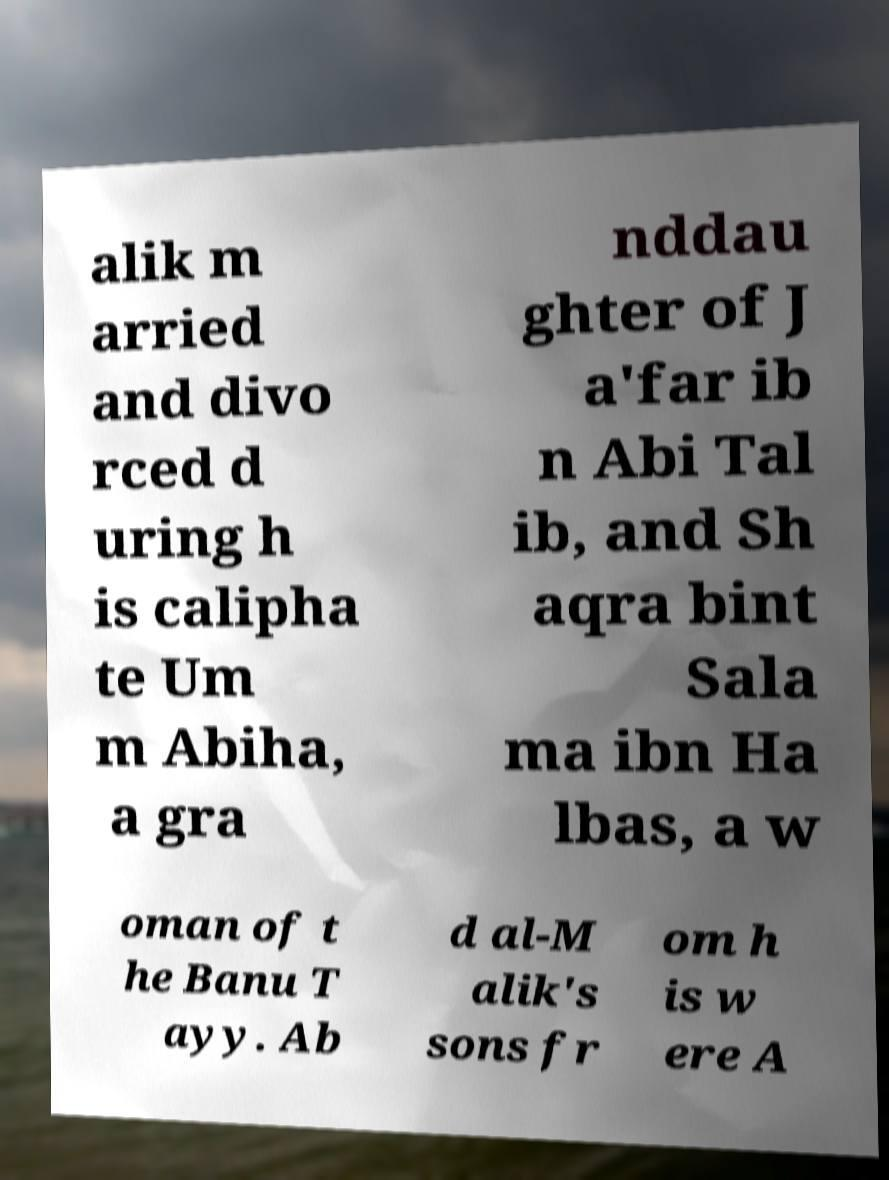What messages or text are displayed in this image? I need them in a readable, typed format. alik m arried and divo rced d uring h is calipha te Um m Abiha, a gra nddau ghter of J a'far ib n Abi Tal ib, and Sh aqra bint Sala ma ibn Ha lbas, a w oman of t he Banu T ayy. Ab d al-M alik's sons fr om h is w ere A 